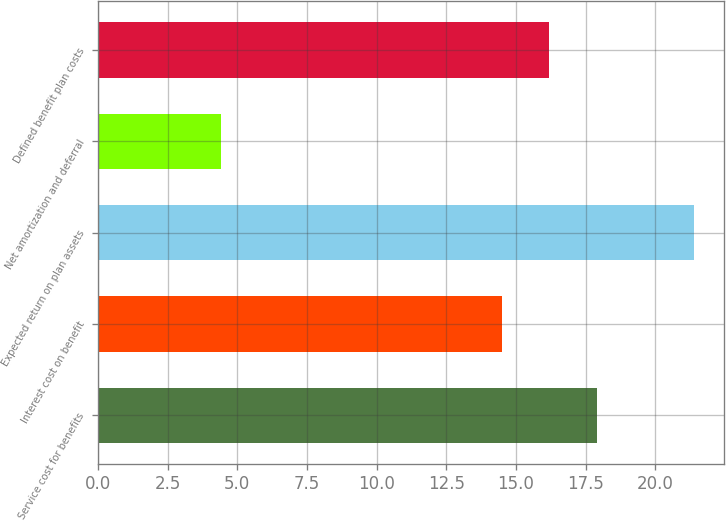Convert chart to OTSL. <chart><loc_0><loc_0><loc_500><loc_500><bar_chart><fcel>Service cost for benefits<fcel>Interest cost on benefit<fcel>Expected return on plan assets<fcel>Net amortization and deferral<fcel>Defined benefit plan costs<nl><fcel>17.9<fcel>14.5<fcel>21.4<fcel>4.4<fcel>16.2<nl></chart> 